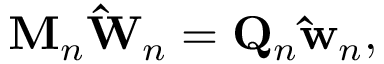Convert formula to latex. <formula><loc_0><loc_0><loc_500><loc_500>M _ { n } \hat { W } _ { n } = Q _ { n } \hat { w } _ { n } ,</formula> 